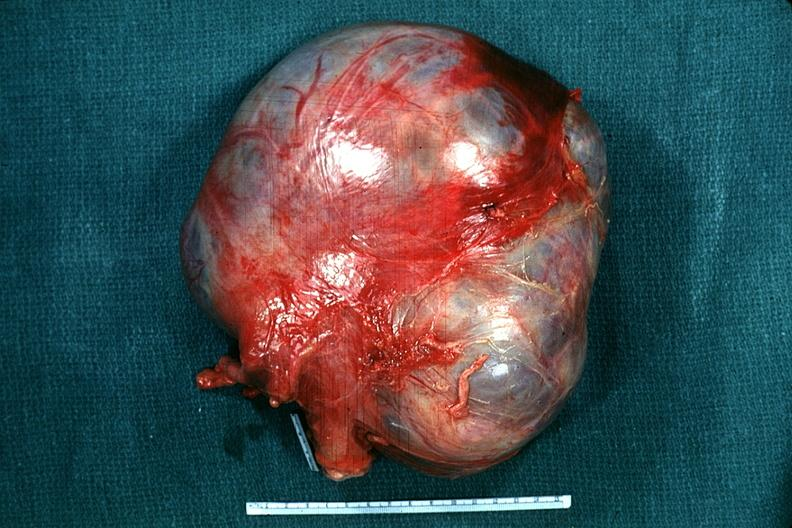s no tissue recognizable as ovary present?
Answer the question using a single word or phrase. Yes 